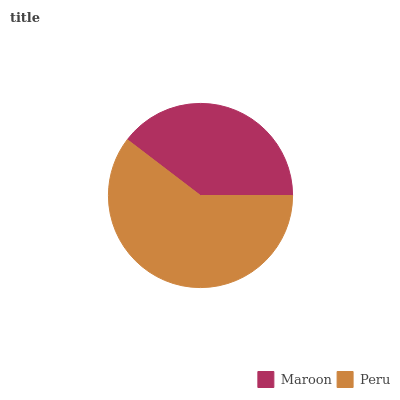Is Maroon the minimum?
Answer yes or no. Yes. Is Peru the maximum?
Answer yes or no. Yes. Is Peru the minimum?
Answer yes or no. No. Is Peru greater than Maroon?
Answer yes or no. Yes. Is Maroon less than Peru?
Answer yes or no. Yes. Is Maroon greater than Peru?
Answer yes or no. No. Is Peru less than Maroon?
Answer yes or no. No. Is Peru the high median?
Answer yes or no. Yes. Is Maroon the low median?
Answer yes or no. Yes. Is Maroon the high median?
Answer yes or no. No. Is Peru the low median?
Answer yes or no. No. 